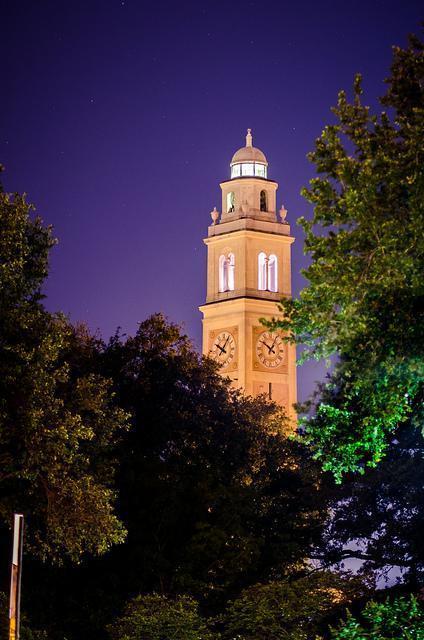How many clock faces do you see?
Give a very brief answer. 2. How many people are standing?
Give a very brief answer. 0. 